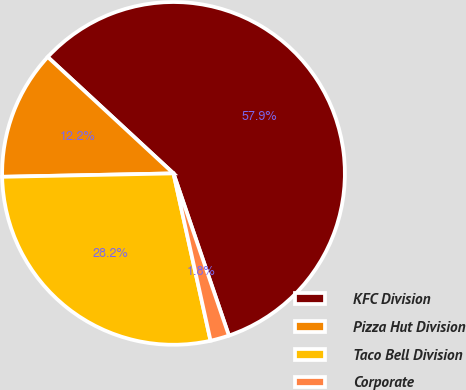Convert chart to OTSL. <chart><loc_0><loc_0><loc_500><loc_500><pie_chart><fcel>KFC Division<fcel>Pizza Hut Division<fcel>Taco Bell Division<fcel>Corporate<nl><fcel>57.87%<fcel>12.2%<fcel>28.15%<fcel>1.77%<nl></chart> 